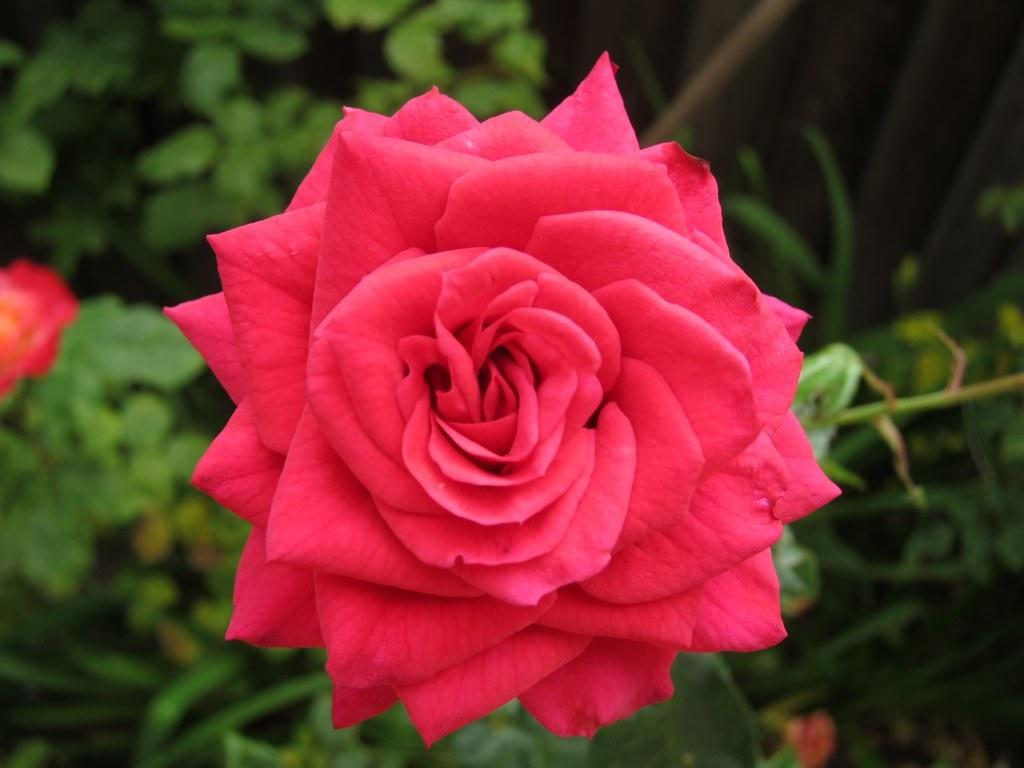What is the main subject in the foreground of the image? There is a rose flower in the foreground of the image. What can be seen in the background of the image? There are plants and flowers in the background of the image. What type of yak can be seen grazing among the flowers in the image? There is no yak present in the image; it features a rose flower in the foreground and plants and flowers in the background. 